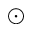Convert formula to latex. <formula><loc_0><loc_0><loc_500><loc_500>\odot</formula> 